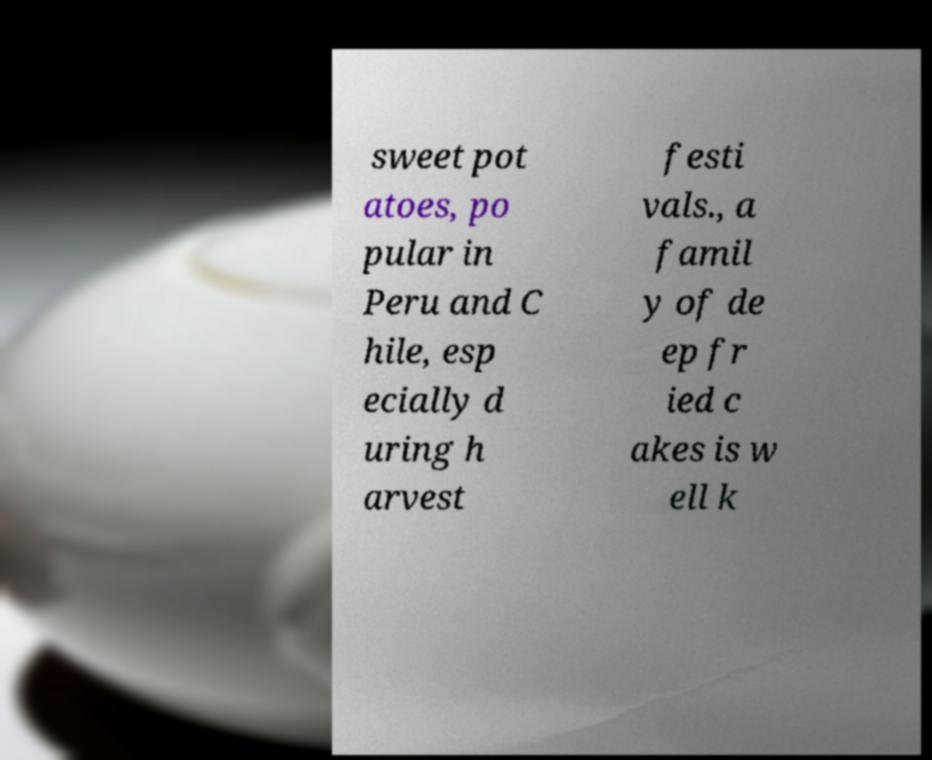For documentation purposes, I need the text within this image transcribed. Could you provide that? sweet pot atoes, po pular in Peru and C hile, esp ecially d uring h arvest festi vals., a famil y of de ep fr ied c akes is w ell k 